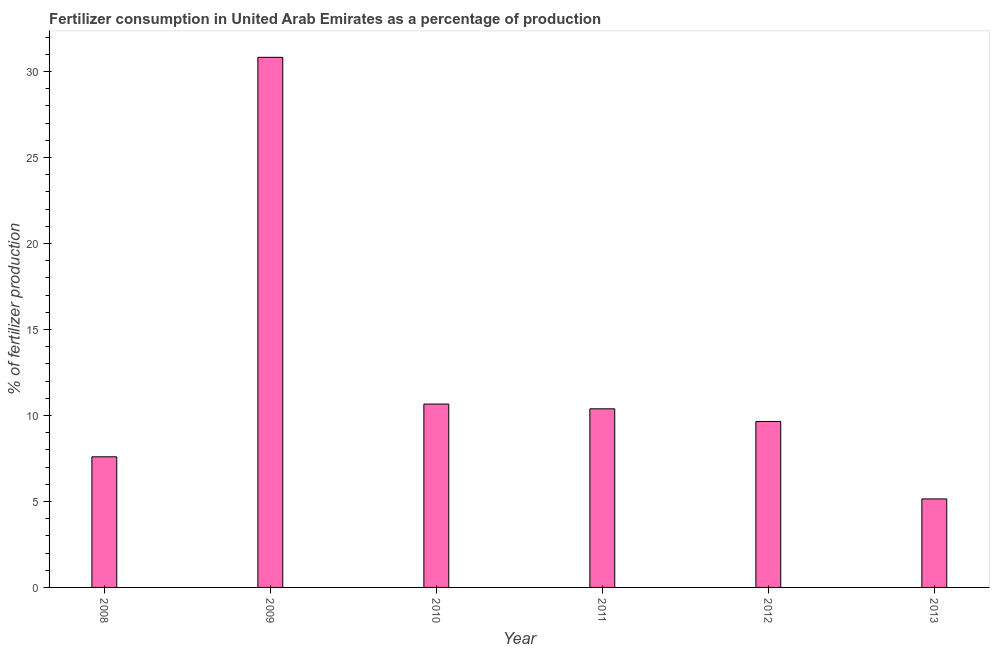Does the graph contain any zero values?
Give a very brief answer. No. Does the graph contain grids?
Your answer should be very brief. No. What is the title of the graph?
Provide a succinct answer. Fertilizer consumption in United Arab Emirates as a percentage of production. What is the label or title of the X-axis?
Offer a terse response. Year. What is the label or title of the Y-axis?
Ensure brevity in your answer.  % of fertilizer production. What is the amount of fertilizer consumption in 2009?
Provide a short and direct response. 30.83. Across all years, what is the maximum amount of fertilizer consumption?
Provide a succinct answer. 30.83. Across all years, what is the minimum amount of fertilizer consumption?
Your response must be concise. 5.15. What is the sum of the amount of fertilizer consumption?
Provide a succinct answer. 74.28. What is the difference between the amount of fertilizer consumption in 2011 and 2013?
Offer a very short reply. 5.24. What is the average amount of fertilizer consumption per year?
Offer a very short reply. 12.38. What is the median amount of fertilizer consumption?
Your answer should be very brief. 10.02. In how many years, is the amount of fertilizer consumption greater than 26 %?
Ensure brevity in your answer.  1. Do a majority of the years between 2008 and 2011 (inclusive) have amount of fertilizer consumption greater than 16 %?
Ensure brevity in your answer.  No. What is the ratio of the amount of fertilizer consumption in 2009 to that in 2011?
Your response must be concise. 2.97. What is the difference between the highest and the second highest amount of fertilizer consumption?
Offer a very short reply. 20.17. What is the difference between the highest and the lowest amount of fertilizer consumption?
Your answer should be very brief. 25.68. In how many years, is the amount of fertilizer consumption greater than the average amount of fertilizer consumption taken over all years?
Make the answer very short. 1. How many bars are there?
Your response must be concise. 6. How many years are there in the graph?
Offer a terse response. 6. Are the values on the major ticks of Y-axis written in scientific E-notation?
Provide a succinct answer. No. What is the % of fertilizer production in 2008?
Your answer should be compact. 7.6. What is the % of fertilizer production in 2009?
Give a very brief answer. 30.83. What is the % of fertilizer production of 2010?
Keep it short and to the point. 10.66. What is the % of fertilizer production in 2011?
Provide a short and direct response. 10.39. What is the % of fertilizer production in 2012?
Offer a very short reply. 9.65. What is the % of fertilizer production in 2013?
Your answer should be compact. 5.15. What is the difference between the % of fertilizer production in 2008 and 2009?
Offer a very short reply. -23.23. What is the difference between the % of fertilizer production in 2008 and 2010?
Offer a very short reply. -3.07. What is the difference between the % of fertilizer production in 2008 and 2011?
Your response must be concise. -2.79. What is the difference between the % of fertilizer production in 2008 and 2012?
Offer a terse response. -2.05. What is the difference between the % of fertilizer production in 2008 and 2013?
Ensure brevity in your answer.  2.45. What is the difference between the % of fertilizer production in 2009 and 2010?
Your answer should be compact. 20.17. What is the difference between the % of fertilizer production in 2009 and 2011?
Offer a terse response. 20.44. What is the difference between the % of fertilizer production in 2009 and 2012?
Provide a succinct answer. 21.18. What is the difference between the % of fertilizer production in 2009 and 2013?
Ensure brevity in your answer.  25.68. What is the difference between the % of fertilizer production in 2010 and 2011?
Offer a very short reply. 0.28. What is the difference between the % of fertilizer production in 2010 and 2012?
Ensure brevity in your answer.  1.01. What is the difference between the % of fertilizer production in 2010 and 2013?
Provide a short and direct response. 5.52. What is the difference between the % of fertilizer production in 2011 and 2012?
Provide a short and direct response. 0.74. What is the difference between the % of fertilizer production in 2011 and 2013?
Give a very brief answer. 5.24. What is the difference between the % of fertilizer production in 2012 and 2013?
Offer a terse response. 4.5. What is the ratio of the % of fertilizer production in 2008 to that in 2009?
Your answer should be very brief. 0.25. What is the ratio of the % of fertilizer production in 2008 to that in 2010?
Your response must be concise. 0.71. What is the ratio of the % of fertilizer production in 2008 to that in 2011?
Your answer should be very brief. 0.73. What is the ratio of the % of fertilizer production in 2008 to that in 2012?
Your answer should be compact. 0.79. What is the ratio of the % of fertilizer production in 2008 to that in 2013?
Provide a short and direct response. 1.48. What is the ratio of the % of fertilizer production in 2009 to that in 2010?
Offer a terse response. 2.89. What is the ratio of the % of fertilizer production in 2009 to that in 2011?
Offer a terse response. 2.97. What is the ratio of the % of fertilizer production in 2009 to that in 2012?
Offer a terse response. 3.19. What is the ratio of the % of fertilizer production in 2009 to that in 2013?
Your response must be concise. 5.99. What is the ratio of the % of fertilizer production in 2010 to that in 2012?
Offer a terse response. 1.1. What is the ratio of the % of fertilizer production in 2010 to that in 2013?
Give a very brief answer. 2.07. What is the ratio of the % of fertilizer production in 2011 to that in 2012?
Keep it short and to the point. 1.08. What is the ratio of the % of fertilizer production in 2011 to that in 2013?
Offer a terse response. 2.02. What is the ratio of the % of fertilizer production in 2012 to that in 2013?
Provide a short and direct response. 1.88. 